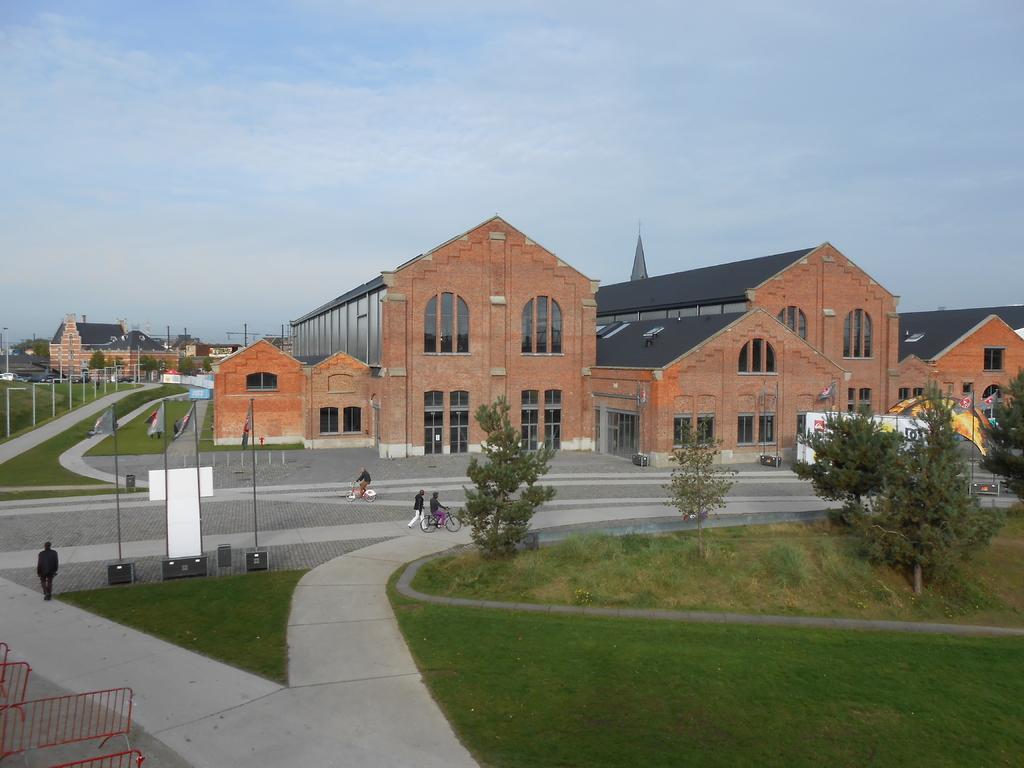Can you describe this image briefly? In the picture we can see a grass surface with some trees on it and beside it, we can see a road with some people riding a bicycle and behind them, we can see some buildings and near to it, we can see a van and some poles with flags on the path and in the background we can see the sky with clouds. 